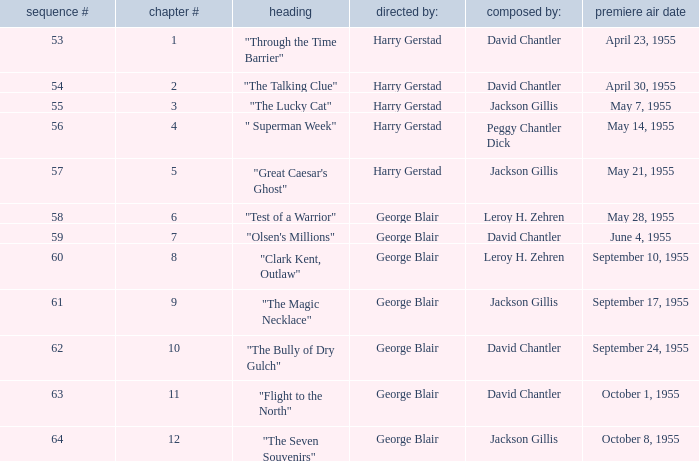Who was "The Magic Necklace" written by? Jackson Gillis. 